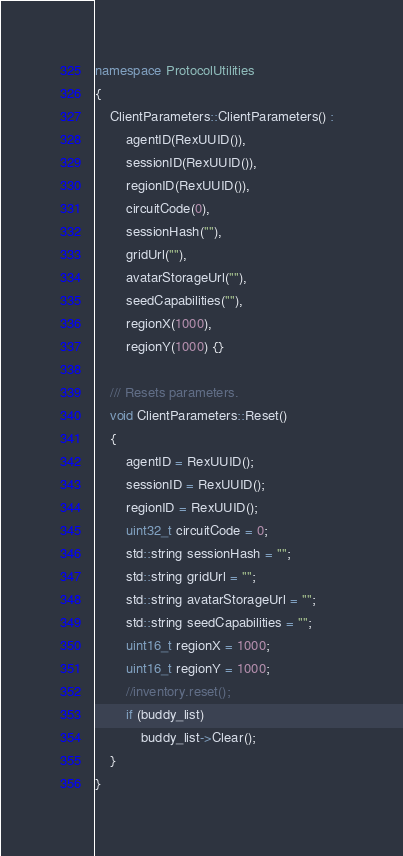<code> <loc_0><loc_0><loc_500><loc_500><_C++_>namespace ProtocolUtilities
{
    ClientParameters::ClientParameters() :
        agentID(RexUUID()),
        sessionID(RexUUID()),
        regionID(RexUUID()),
        circuitCode(0),
        sessionHash(""),
        gridUrl(""),
        avatarStorageUrl(""),
        seedCapabilities(""),
        regionX(1000),
        regionY(1000) {}

    /// Resets parameters.
    void ClientParameters::Reset()
    {
        agentID = RexUUID();
        sessionID = RexUUID();
        regionID = RexUUID();
        uint32_t circuitCode = 0;
        std::string sessionHash = "";
        std::string gridUrl = "";
        std::string avatarStorageUrl = "";
        std::string seedCapabilities = "";        
        uint16_t regionX = 1000;
        uint16_t regionY = 1000;
        //inventory.reset();
        if (buddy_list)
            buddy_list->Clear();
    }
}
</code> 